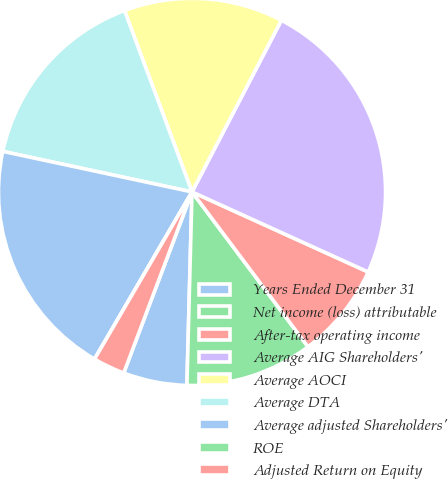Convert chart to OTSL. <chart><loc_0><loc_0><loc_500><loc_500><pie_chart><fcel>Years Ended December 31<fcel>Net income (loss) attributable<fcel>After-tax operating income<fcel>Average AIG Shareholders'<fcel>Average AOCI<fcel>Average DTA<fcel>Average adjusted Shareholders'<fcel>ROE<fcel>Adjusted Return on Equity<nl><fcel>5.32%<fcel>10.65%<fcel>7.98%<fcel>24.15%<fcel>13.31%<fcel>15.97%<fcel>19.96%<fcel>0.0%<fcel>2.66%<nl></chart> 